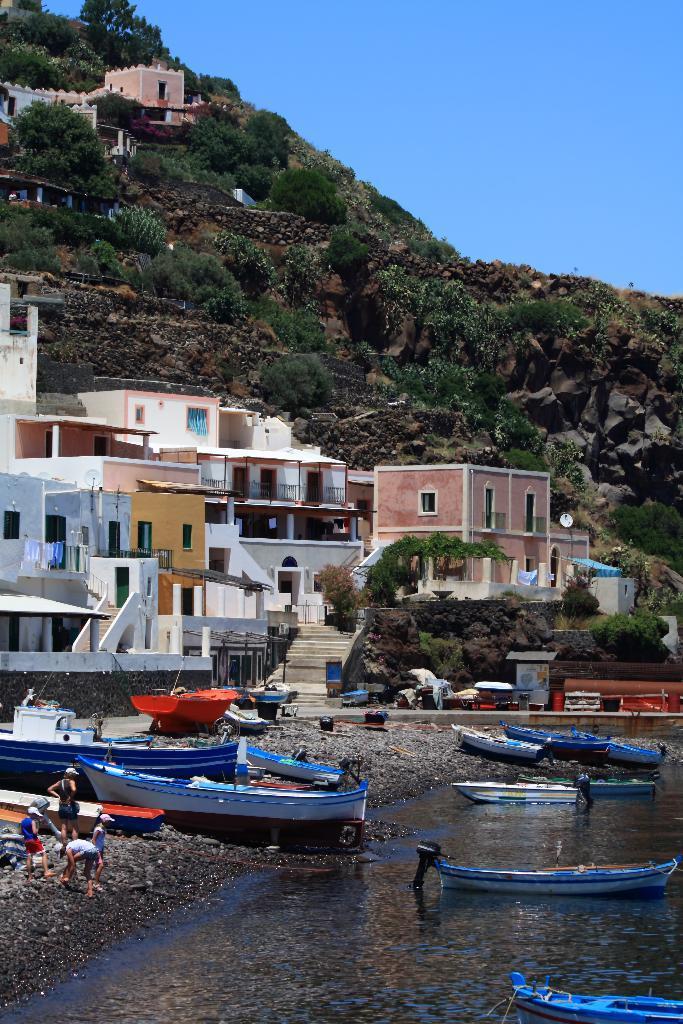In one or two sentences, can you explain what this image depicts? In this picture I can observe buildings in the middle of the picture. In the bottom of the picture I can observe boats floating on the water. In the background I can observe some plants and trees on the hill. I can observe sky in the background. 